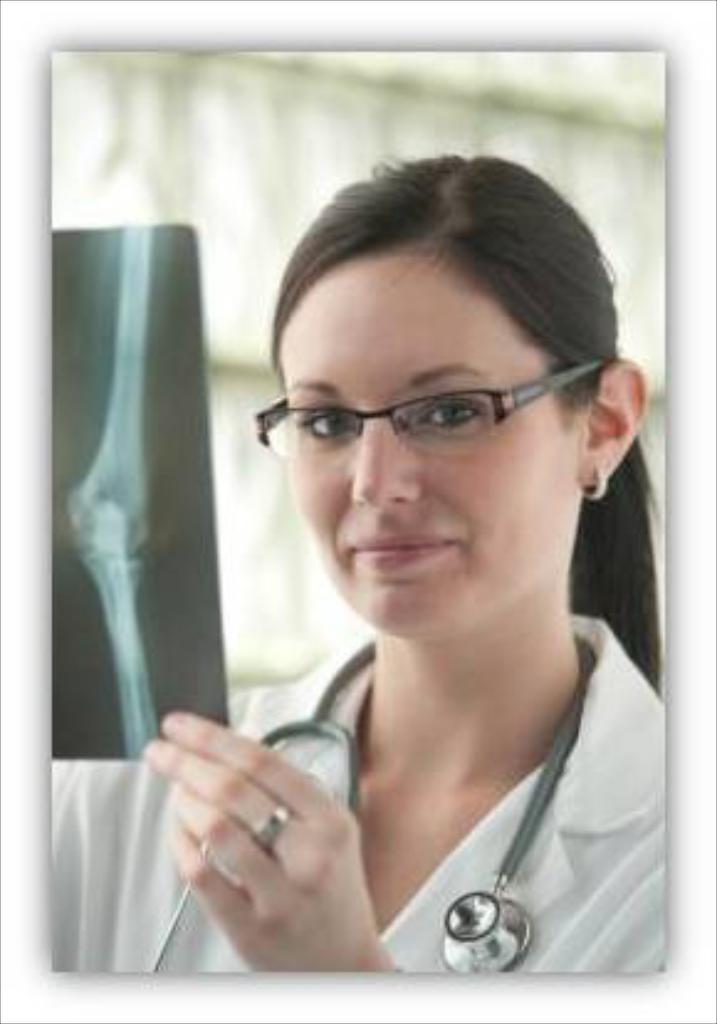How would you summarize this image in a sentence or two? In this image I can see a person holding x-ray sheet. The person is wearing white color coat and stethoscope, and I can see white color background. 